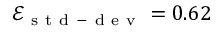Convert formula to latex. <formula><loc_0><loc_0><loc_500><loc_500>\mathcal { E } _ { s t d - d e v } = 0 . 6 2</formula> 